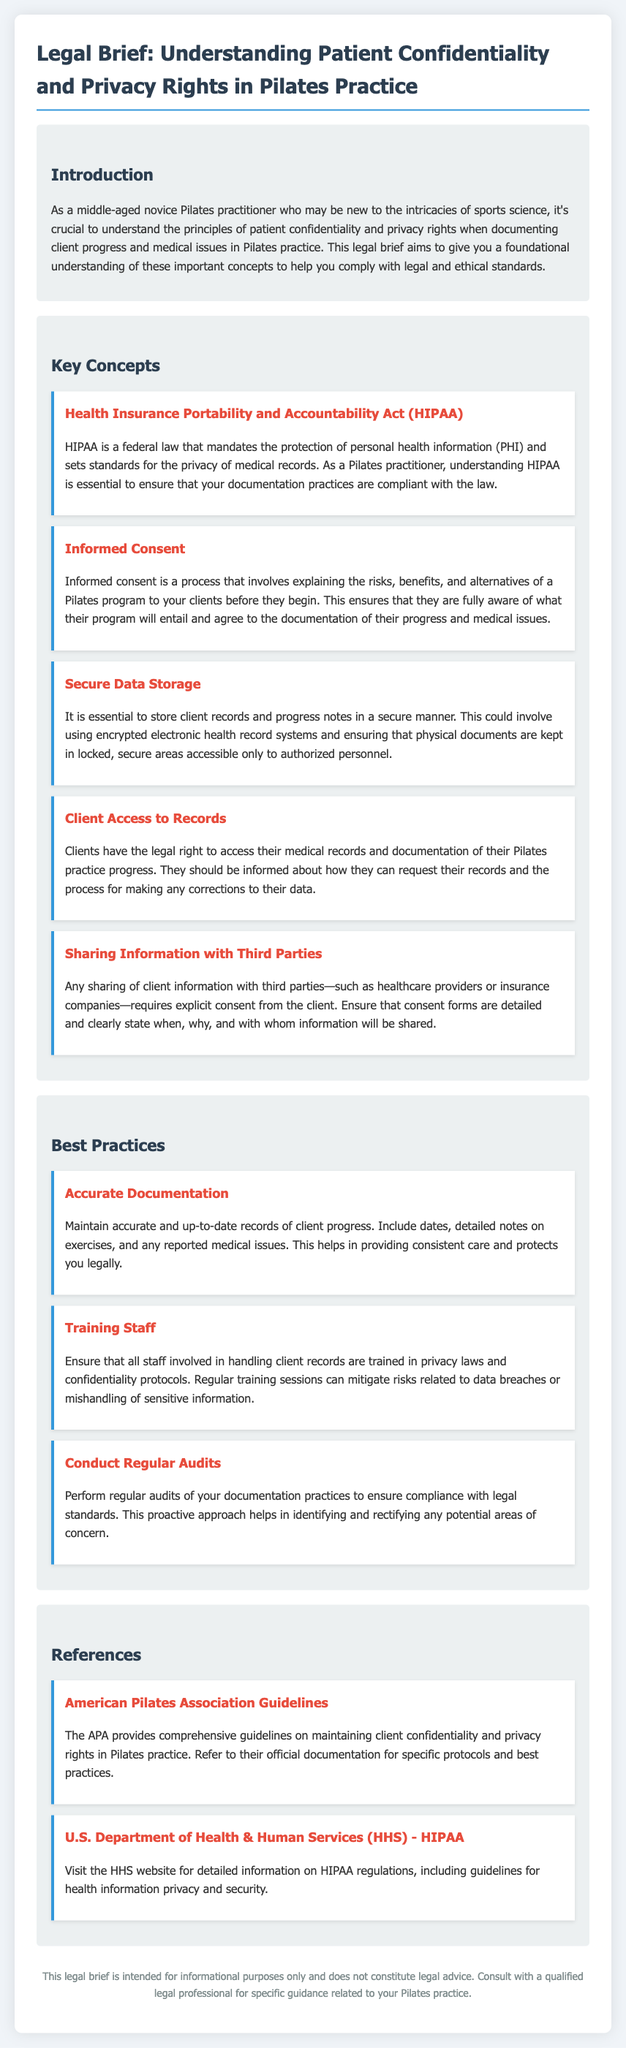What is HIPAA? HIPAA is a federal law that mandates the protection of personal health information (PHI) and sets standards for the privacy of medical records.
Answer: a federal law What does informed consent ensure? Informed consent ensures that clients are fully aware of what their program will entail and agree to the documentation of their progress and medical issues.
Answer: full awareness What is required for sharing client information? Any sharing of client information with third parties requires explicit consent from the client.
Answer: explicit consent What should be maintained for accurate documentation? Accurate documentation should maintain records of client progress, including dates and detailed notes on exercises.
Answer: records of client progress Who should be trained in privacy laws? All staff involved in handling client records should be trained in privacy laws and confidentiality protocols.
Answer: all staff What is the purpose of regular audits? Regular audits help in identifying and rectifying any potential areas of concern regarding documentation practices.
Answer: compliance What type of guidelines does the American Pilates Association provide? The APA provides comprehensive guidelines on maintaining client confidentiality and privacy rights.
Answer: comprehensive guidelines What is the intention of this legal brief? This legal brief is intended for informational purposes only and does not constitute legal advice.
Answer: informational purposes only What is a best practice for documentation? A best practice for documentation is to maintain accurate and up-to-date records of client progress.
Answer: accurate and up-to-date records 